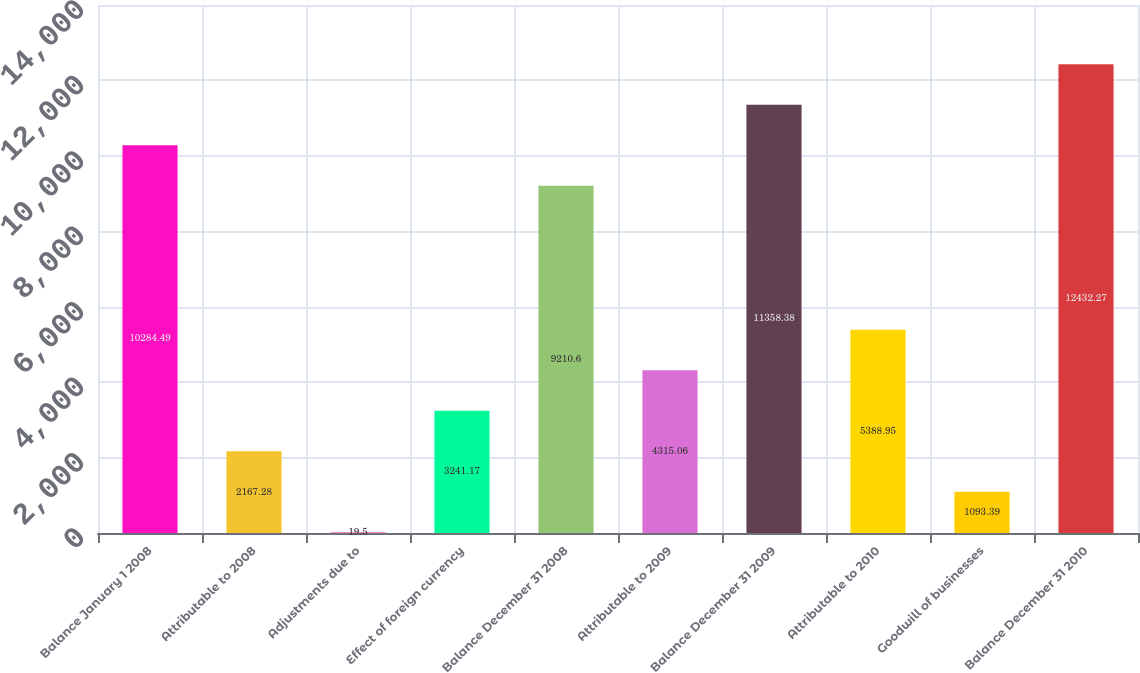<chart> <loc_0><loc_0><loc_500><loc_500><bar_chart><fcel>Balance January 1 2008<fcel>Attributable to 2008<fcel>Adjustments due to<fcel>Effect of foreign currency<fcel>Balance December 31 2008<fcel>Attributable to 2009<fcel>Balance December 31 2009<fcel>Attributable to 2010<fcel>Goodwill of businesses<fcel>Balance December 31 2010<nl><fcel>10284.5<fcel>2167.28<fcel>19.5<fcel>3241.17<fcel>9210.6<fcel>4315.06<fcel>11358.4<fcel>5388.95<fcel>1093.39<fcel>12432.3<nl></chart> 